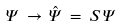<formula> <loc_0><loc_0><loc_500><loc_500>\Psi \, \to \, \hat { \Psi } \, = \, S \, \Psi</formula> 